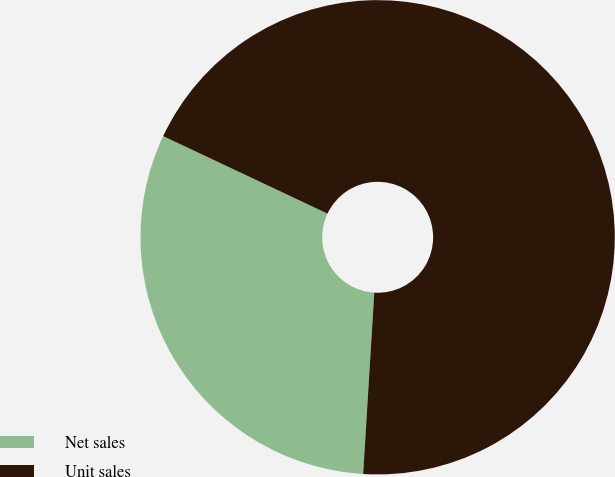Convert chart. <chart><loc_0><loc_0><loc_500><loc_500><pie_chart><fcel>Net sales<fcel>Unit sales<nl><fcel>31.04%<fcel>68.96%<nl></chart> 